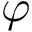Convert formula to latex. <formula><loc_0><loc_0><loc_500><loc_500>\varphi</formula> 